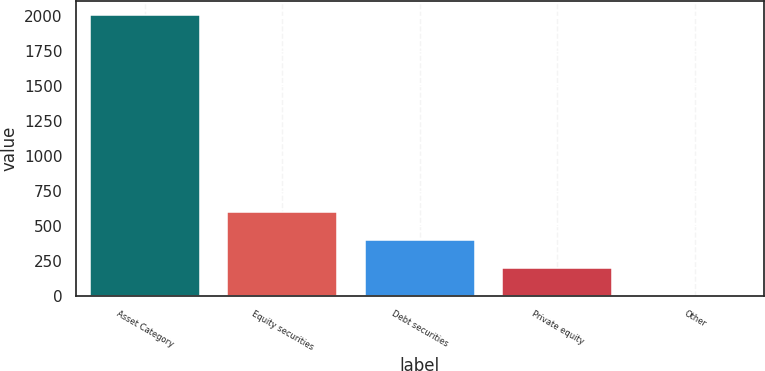Convert chart. <chart><loc_0><loc_0><loc_500><loc_500><bar_chart><fcel>Asset Category<fcel>Equity securities<fcel>Debt securities<fcel>Private equity<fcel>Other<nl><fcel>2007<fcel>602.8<fcel>402.2<fcel>201.6<fcel>1<nl></chart> 